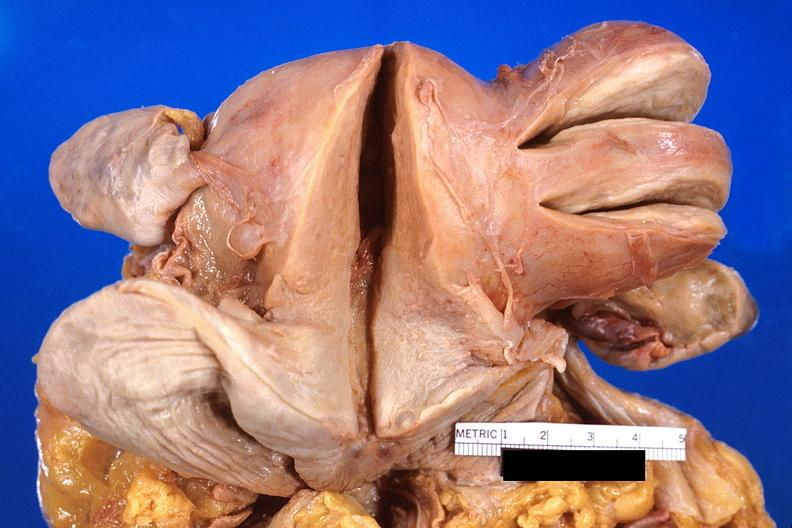does this image show uterus, leiomyoma?
Answer the question using a single word or phrase. Yes 